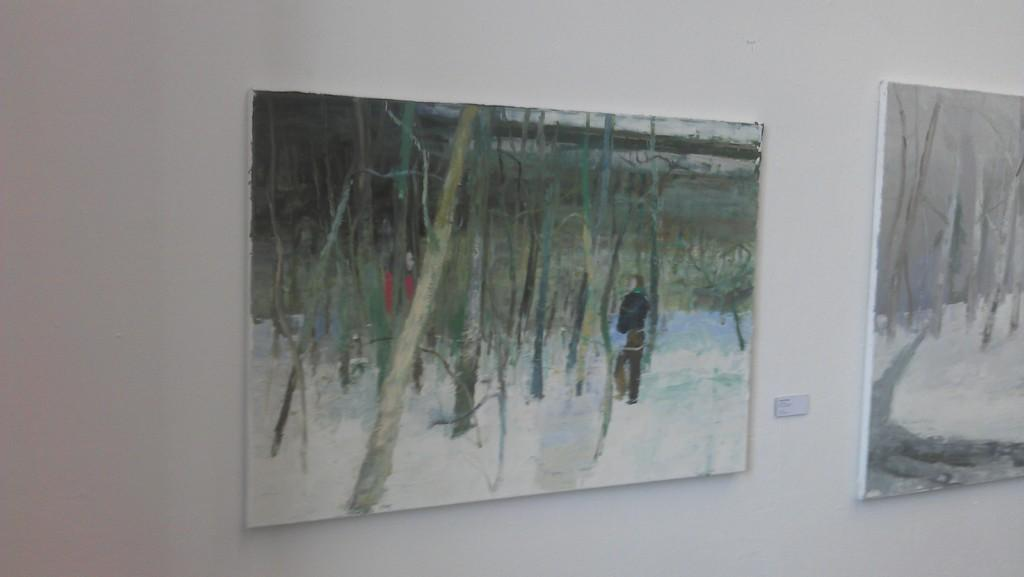How many photo frames can be seen in the image? There are two photo frames in the image. What else is present on the wall in the image? There is an object on the wall in the image. What type of hat is hanging on the wall in the image? There is no hat present in the image; only photo frames and an unspecified object on the wall are visible. 